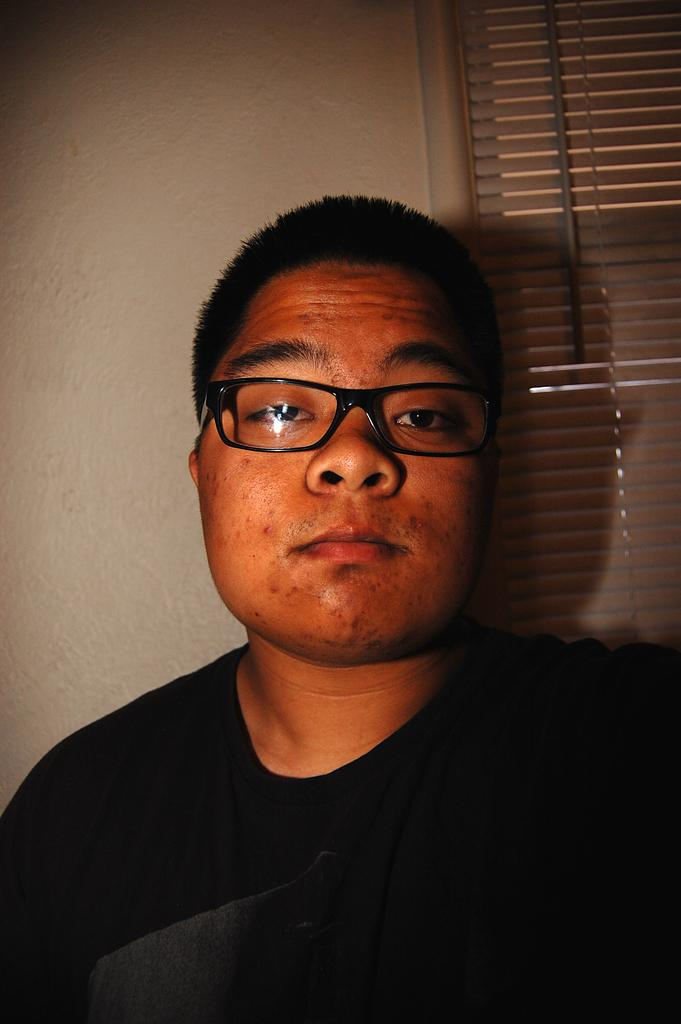Who is present in the image? There is a man in the image. What is the man wearing? The man is wearing a black t-shirt. What can be seen in the background of the image? There is a wall in the background of the image. Is there any opening in the wall? Yes, there is a window in the wall. What invention is the man holding in the image? There is no invention visible in the image; the man is simply wearing a black t-shirt and standing in front of a wall with a window. 